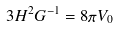Convert formula to latex. <formula><loc_0><loc_0><loc_500><loc_500>3 H ^ { 2 } G ^ { - 1 } = 8 \pi V _ { 0 }</formula> 